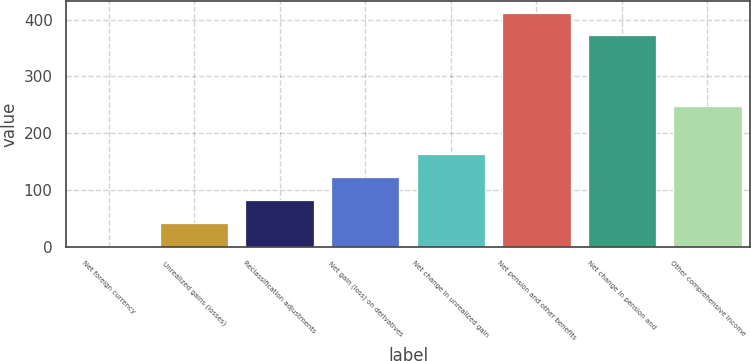Convert chart. <chart><loc_0><loc_0><loc_500><loc_500><bar_chart><fcel>Net foreign currency<fcel>Unrealized gains (losses)<fcel>Reclassification adjustments<fcel>Net gain (loss) on derivatives<fcel>Net change in unrealized gain<fcel>Net pension and other benefits<fcel>Net change in pension and<fcel>Other comprehensive income<nl><fcel>1<fcel>41.4<fcel>81.8<fcel>122.2<fcel>162.6<fcel>412.4<fcel>372<fcel>247<nl></chart> 